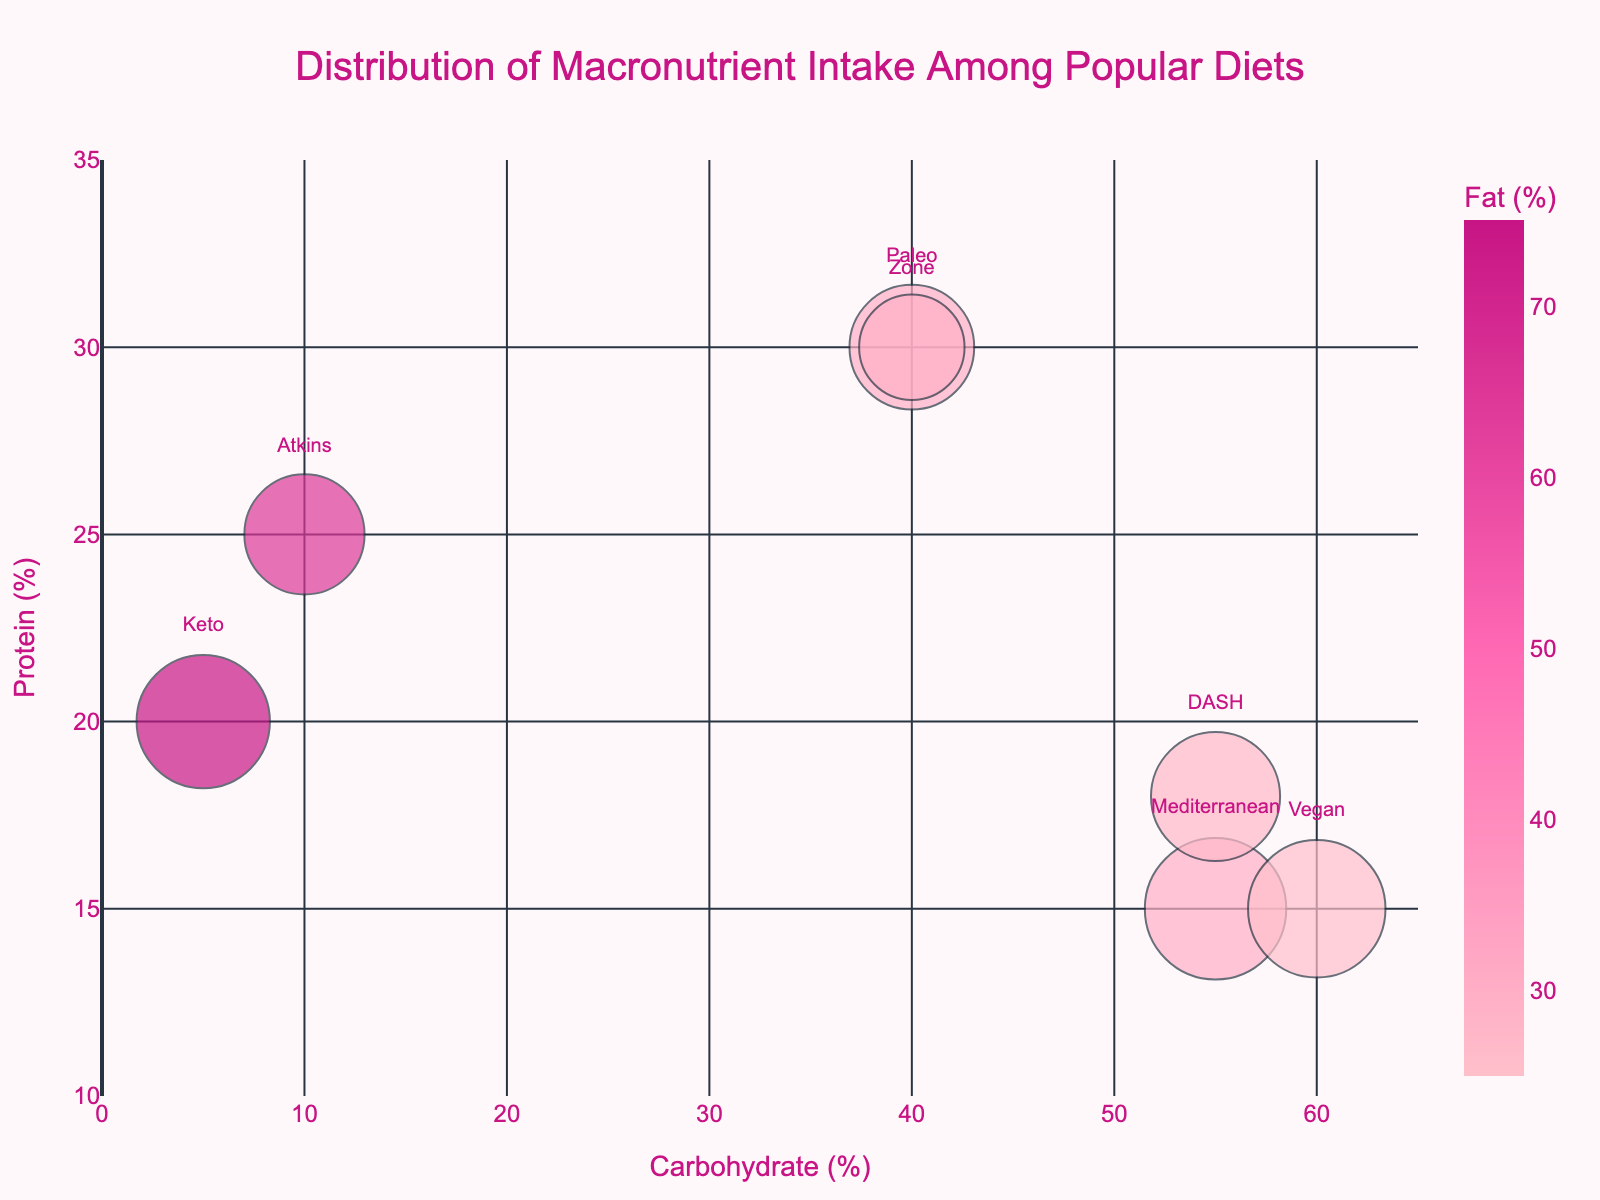What's the title of the chart? The title is located at the top of the chart and reads "Distribution of Macronutrient Intake Among Popular Diets"
Answer: Distribution of Macronutrient Intake Among Popular Diets What are the axis labels in the figure? The x-axis label reads "Carbohydrate (%)" and the y-axis label reads "Protein (%)"
Answer: Carbohydrate (%) and Protein (%) Which diet has the highest carbohydrate percentage? By scanning the x-axis for the highest carbohydrate value, the Mediterranean diet has 55%.
Answer: Mediterranean Which diets include a note about caloric restriction? There is an annotation at the bottom of the chart listing diets with caloric restriction: Keto, Atkins, and Zone.
Answer: Keto, Atkins, Zone What is the range of protein percentages shown on the y-axis? The y-axis is labeled from 10% to 35% in increments of 5%.
Answer: 10% to 35% How are the bubble sizes determined? The explanation mentions that bubble sizes are calculated based on popularity, with the size scaled by 0.5.
Answer: Based on popularity Which diet has the largest bubble size? By observing the figure, the Mediterranean diet has the largest bubble size, indicating the highest popularity.
Answer: Mediterranean Between Keto and DASH diets, which one has a higher fat percentage? Comparing the color legend for fat percentages, Keto's value is 75%, and DASH's value is 27%. Keto has a higher fat percentage.
Answer: Keto What are the protein and carbohydrate percentages for the Zone diet? Locate the Zone diet bubble and hover over it to see that it lists 30% protein and 40% carbohydrates in the hover text.
Answer: 30% protein and 40% carbohydrates Which diet has the highest fat percentage and what is it? By looking at the color legend, the Keto diet has the highest fat percentage of 75%.
Answer: Keto, 75% 